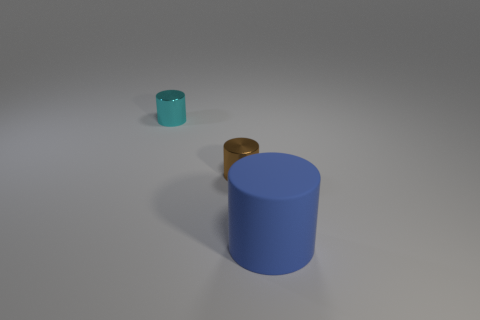Add 3 tiny cyan things. How many objects exist? 6 Subtract all cyan matte objects. Subtract all brown metallic things. How many objects are left? 2 Add 3 large cylinders. How many large cylinders are left? 4 Add 3 metal cylinders. How many metal cylinders exist? 5 Subtract 0 green cylinders. How many objects are left? 3 